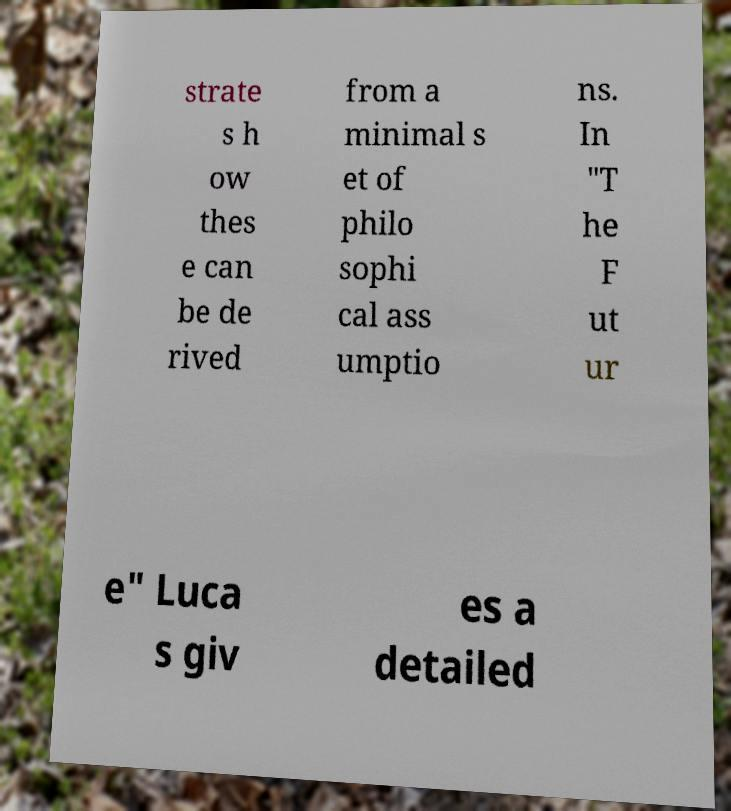Please read and relay the text visible in this image. What does it say? strate s h ow thes e can be de rived from a minimal s et of philo sophi cal ass umptio ns. In "T he F ut ur e" Luca s giv es a detailed 